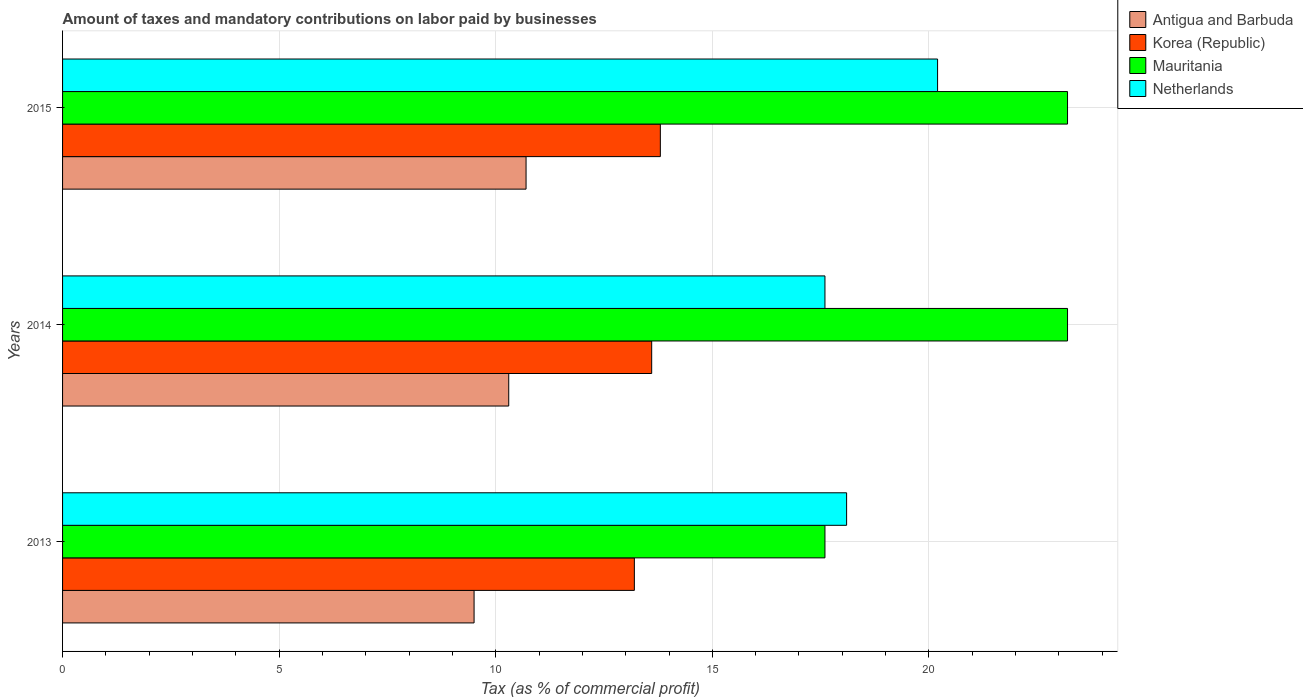Are the number of bars per tick equal to the number of legend labels?
Keep it short and to the point. Yes. How many bars are there on the 1st tick from the top?
Offer a terse response. 4. How many bars are there on the 2nd tick from the bottom?
Your answer should be very brief. 4. What is the label of the 2nd group of bars from the top?
Your response must be concise. 2014. Across all years, what is the maximum percentage of taxes paid by businesses in Korea (Republic)?
Provide a short and direct response. 13.8. Across all years, what is the minimum percentage of taxes paid by businesses in Korea (Republic)?
Your answer should be very brief. 13.2. What is the total percentage of taxes paid by businesses in Antigua and Barbuda in the graph?
Ensure brevity in your answer.  30.5. What is the difference between the percentage of taxes paid by businesses in Mauritania in 2014 and that in 2015?
Provide a short and direct response. 0. What is the difference between the percentage of taxes paid by businesses in Netherlands in 2014 and the percentage of taxes paid by businesses in Mauritania in 2015?
Provide a succinct answer. -5.6. What is the average percentage of taxes paid by businesses in Korea (Republic) per year?
Your answer should be compact. 13.53. In the year 2014, what is the difference between the percentage of taxes paid by businesses in Netherlands and percentage of taxes paid by businesses in Korea (Republic)?
Provide a short and direct response. 4. In how many years, is the percentage of taxes paid by businesses in Antigua and Barbuda greater than 16 %?
Provide a short and direct response. 0. What is the ratio of the percentage of taxes paid by businesses in Mauritania in 2013 to that in 2014?
Keep it short and to the point. 0.76. Is the percentage of taxes paid by businesses in Antigua and Barbuda in 2013 less than that in 2014?
Keep it short and to the point. Yes. What is the difference between the highest and the second highest percentage of taxes paid by businesses in Korea (Republic)?
Offer a very short reply. 0.2. What is the difference between the highest and the lowest percentage of taxes paid by businesses in Korea (Republic)?
Keep it short and to the point. 0.6. In how many years, is the percentage of taxes paid by businesses in Netherlands greater than the average percentage of taxes paid by businesses in Netherlands taken over all years?
Your answer should be very brief. 1. Is the sum of the percentage of taxes paid by businesses in Antigua and Barbuda in 2013 and 2015 greater than the maximum percentage of taxes paid by businesses in Netherlands across all years?
Offer a terse response. No. Is it the case that in every year, the sum of the percentage of taxes paid by businesses in Korea (Republic) and percentage of taxes paid by businesses in Antigua and Barbuda is greater than the sum of percentage of taxes paid by businesses in Netherlands and percentage of taxes paid by businesses in Mauritania?
Your response must be concise. No. What does the 3rd bar from the top in 2015 represents?
Your answer should be very brief. Korea (Republic). Where does the legend appear in the graph?
Your answer should be very brief. Top right. What is the title of the graph?
Keep it short and to the point. Amount of taxes and mandatory contributions on labor paid by businesses. Does "Ukraine" appear as one of the legend labels in the graph?
Offer a terse response. No. What is the label or title of the X-axis?
Ensure brevity in your answer.  Tax (as % of commercial profit). What is the Tax (as % of commercial profit) of Antigua and Barbuda in 2013?
Offer a very short reply. 9.5. What is the Tax (as % of commercial profit) of Mauritania in 2014?
Offer a very short reply. 23.2. What is the Tax (as % of commercial profit) of Antigua and Barbuda in 2015?
Offer a terse response. 10.7. What is the Tax (as % of commercial profit) in Korea (Republic) in 2015?
Provide a succinct answer. 13.8. What is the Tax (as % of commercial profit) in Mauritania in 2015?
Give a very brief answer. 23.2. What is the Tax (as % of commercial profit) in Netherlands in 2015?
Your response must be concise. 20.2. Across all years, what is the maximum Tax (as % of commercial profit) in Antigua and Barbuda?
Offer a very short reply. 10.7. Across all years, what is the maximum Tax (as % of commercial profit) of Korea (Republic)?
Give a very brief answer. 13.8. Across all years, what is the maximum Tax (as % of commercial profit) in Mauritania?
Offer a very short reply. 23.2. Across all years, what is the maximum Tax (as % of commercial profit) of Netherlands?
Make the answer very short. 20.2. Across all years, what is the minimum Tax (as % of commercial profit) in Mauritania?
Offer a terse response. 17.6. What is the total Tax (as % of commercial profit) in Antigua and Barbuda in the graph?
Provide a succinct answer. 30.5. What is the total Tax (as % of commercial profit) of Korea (Republic) in the graph?
Provide a short and direct response. 40.6. What is the total Tax (as % of commercial profit) of Mauritania in the graph?
Ensure brevity in your answer.  64. What is the total Tax (as % of commercial profit) of Netherlands in the graph?
Offer a terse response. 55.9. What is the difference between the Tax (as % of commercial profit) in Korea (Republic) in 2013 and that in 2015?
Make the answer very short. -0.6. What is the difference between the Tax (as % of commercial profit) of Mauritania in 2013 and that in 2015?
Provide a short and direct response. -5.6. What is the difference between the Tax (as % of commercial profit) in Korea (Republic) in 2014 and that in 2015?
Make the answer very short. -0.2. What is the difference between the Tax (as % of commercial profit) of Netherlands in 2014 and that in 2015?
Provide a succinct answer. -2.6. What is the difference between the Tax (as % of commercial profit) of Antigua and Barbuda in 2013 and the Tax (as % of commercial profit) of Korea (Republic) in 2014?
Your answer should be very brief. -4.1. What is the difference between the Tax (as % of commercial profit) of Antigua and Barbuda in 2013 and the Tax (as % of commercial profit) of Mauritania in 2014?
Ensure brevity in your answer.  -13.7. What is the difference between the Tax (as % of commercial profit) in Korea (Republic) in 2013 and the Tax (as % of commercial profit) in Mauritania in 2014?
Provide a short and direct response. -10. What is the difference between the Tax (as % of commercial profit) in Korea (Republic) in 2013 and the Tax (as % of commercial profit) in Netherlands in 2014?
Make the answer very short. -4.4. What is the difference between the Tax (as % of commercial profit) of Mauritania in 2013 and the Tax (as % of commercial profit) of Netherlands in 2014?
Your response must be concise. 0. What is the difference between the Tax (as % of commercial profit) of Antigua and Barbuda in 2013 and the Tax (as % of commercial profit) of Korea (Republic) in 2015?
Give a very brief answer. -4.3. What is the difference between the Tax (as % of commercial profit) of Antigua and Barbuda in 2013 and the Tax (as % of commercial profit) of Mauritania in 2015?
Offer a very short reply. -13.7. What is the difference between the Tax (as % of commercial profit) of Antigua and Barbuda in 2014 and the Tax (as % of commercial profit) of Korea (Republic) in 2015?
Offer a very short reply. -3.5. What is the difference between the Tax (as % of commercial profit) in Antigua and Barbuda in 2014 and the Tax (as % of commercial profit) in Mauritania in 2015?
Keep it short and to the point. -12.9. What is the difference between the Tax (as % of commercial profit) in Antigua and Barbuda in 2014 and the Tax (as % of commercial profit) in Netherlands in 2015?
Your response must be concise. -9.9. What is the difference between the Tax (as % of commercial profit) in Korea (Republic) in 2014 and the Tax (as % of commercial profit) in Netherlands in 2015?
Provide a succinct answer. -6.6. What is the difference between the Tax (as % of commercial profit) in Mauritania in 2014 and the Tax (as % of commercial profit) in Netherlands in 2015?
Offer a terse response. 3. What is the average Tax (as % of commercial profit) in Antigua and Barbuda per year?
Offer a terse response. 10.17. What is the average Tax (as % of commercial profit) in Korea (Republic) per year?
Your answer should be compact. 13.53. What is the average Tax (as % of commercial profit) of Mauritania per year?
Give a very brief answer. 21.33. What is the average Tax (as % of commercial profit) of Netherlands per year?
Make the answer very short. 18.63. In the year 2013, what is the difference between the Tax (as % of commercial profit) in Antigua and Barbuda and Tax (as % of commercial profit) in Korea (Republic)?
Provide a succinct answer. -3.7. In the year 2013, what is the difference between the Tax (as % of commercial profit) in Antigua and Barbuda and Tax (as % of commercial profit) in Netherlands?
Ensure brevity in your answer.  -8.6. In the year 2013, what is the difference between the Tax (as % of commercial profit) in Korea (Republic) and Tax (as % of commercial profit) in Mauritania?
Offer a very short reply. -4.4. In the year 2013, what is the difference between the Tax (as % of commercial profit) in Mauritania and Tax (as % of commercial profit) in Netherlands?
Your answer should be compact. -0.5. In the year 2014, what is the difference between the Tax (as % of commercial profit) in Antigua and Barbuda and Tax (as % of commercial profit) in Mauritania?
Keep it short and to the point. -12.9. In the year 2014, what is the difference between the Tax (as % of commercial profit) of Antigua and Barbuda and Tax (as % of commercial profit) of Netherlands?
Your response must be concise. -7.3. In the year 2014, what is the difference between the Tax (as % of commercial profit) in Korea (Republic) and Tax (as % of commercial profit) in Mauritania?
Provide a short and direct response. -9.6. In the year 2015, what is the difference between the Tax (as % of commercial profit) of Antigua and Barbuda and Tax (as % of commercial profit) of Korea (Republic)?
Make the answer very short. -3.1. In the year 2015, what is the difference between the Tax (as % of commercial profit) of Antigua and Barbuda and Tax (as % of commercial profit) of Mauritania?
Make the answer very short. -12.5. In the year 2015, what is the difference between the Tax (as % of commercial profit) in Antigua and Barbuda and Tax (as % of commercial profit) in Netherlands?
Your answer should be compact. -9.5. In the year 2015, what is the difference between the Tax (as % of commercial profit) in Korea (Republic) and Tax (as % of commercial profit) in Netherlands?
Your answer should be very brief. -6.4. In the year 2015, what is the difference between the Tax (as % of commercial profit) of Mauritania and Tax (as % of commercial profit) of Netherlands?
Your response must be concise. 3. What is the ratio of the Tax (as % of commercial profit) in Antigua and Barbuda in 2013 to that in 2014?
Provide a short and direct response. 0.92. What is the ratio of the Tax (as % of commercial profit) in Korea (Republic) in 2013 to that in 2014?
Provide a succinct answer. 0.97. What is the ratio of the Tax (as % of commercial profit) in Mauritania in 2013 to that in 2014?
Your response must be concise. 0.76. What is the ratio of the Tax (as % of commercial profit) in Netherlands in 2013 to that in 2014?
Your response must be concise. 1.03. What is the ratio of the Tax (as % of commercial profit) of Antigua and Barbuda in 2013 to that in 2015?
Give a very brief answer. 0.89. What is the ratio of the Tax (as % of commercial profit) in Korea (Republic) in 2013 to that in 2015?
Ensure brevity in your answer.  0.96. What is the ratio of the Tax (as % of commercial profit) in Mauritania in 2013 to that in 2015?
Offer a very short reply. 0.76. What is the ratio of the Tax (as % of commercial profit) of Netherlands in 2013 to that in 2015?
Your answer should be compact. 0.9. What is the ratio of the Tax (as % of commercial profit) in Antigua and Barbuda in 2014 to that in 2015?
Give a very brief answer. 0.96. What is the ratio of the Tax (as % of commercial profit) in Korea (Republic) in 2014 to that in 2015?
Your answer should be compact. 0.99. What is the ratio of the Tax (as % of commercial profit) of Netherlands in 2014 to that in 2015?
Your answer should be very brief. 0.87. What is the difference between the highest and the second highest Tax (as % of commercial profit) in Antigua and Barbuda?
Your response must be concise. 0.4. What is the difference between the highest and the second highest Tax (as % of commercial profit) in Mauritania?
Offer a very short reply. 0. What is the difference between the highest and the lowest Tax (as % of commercial profit) in Antigua and Barbuda?
Provide a short and direct response. 1.2. What is the difference between the highest and the lowest Tax (as % of commercial profit) of Korea (Republic)?
Offer a very short reply. 0.6. What is the difference between the highest and the lowest Tax (as % of commercial profit) in Mauritania?
Offer a terse response. 5.6. What is the difference between the highest and the lowest Tax (as % of commercial profit) in Netherlands?
Make the answer very short. 2.6. 